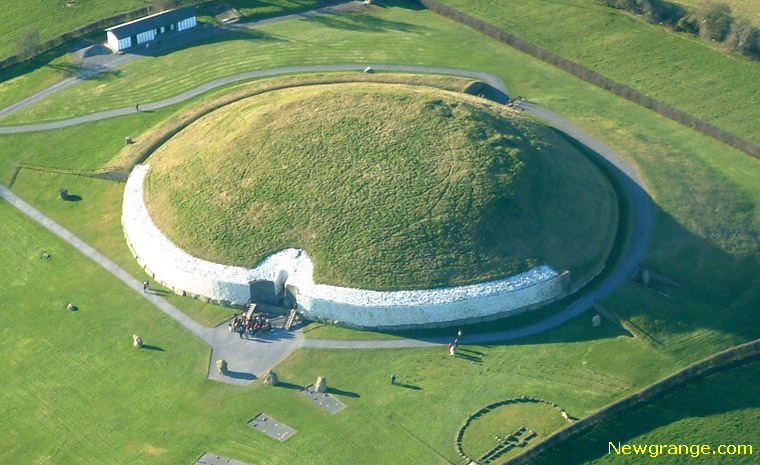What modern elements do you notice around Newgrange? The environs of Newgrange blend ancient and modern elements seamlessly. Visible in the image are a few buildings, possibly visitor centers and facilities, catering to tourists who visit this iconic landmark. There are also pathways and roads crisscrossing the lush green fields, facilitating access to and around the site. These modern amenities ensure that the historical integrity of Newgrange is preserved while making it accessible for present-day exploration and education. 